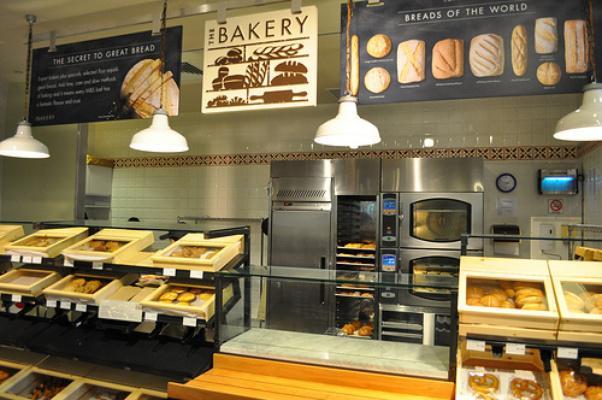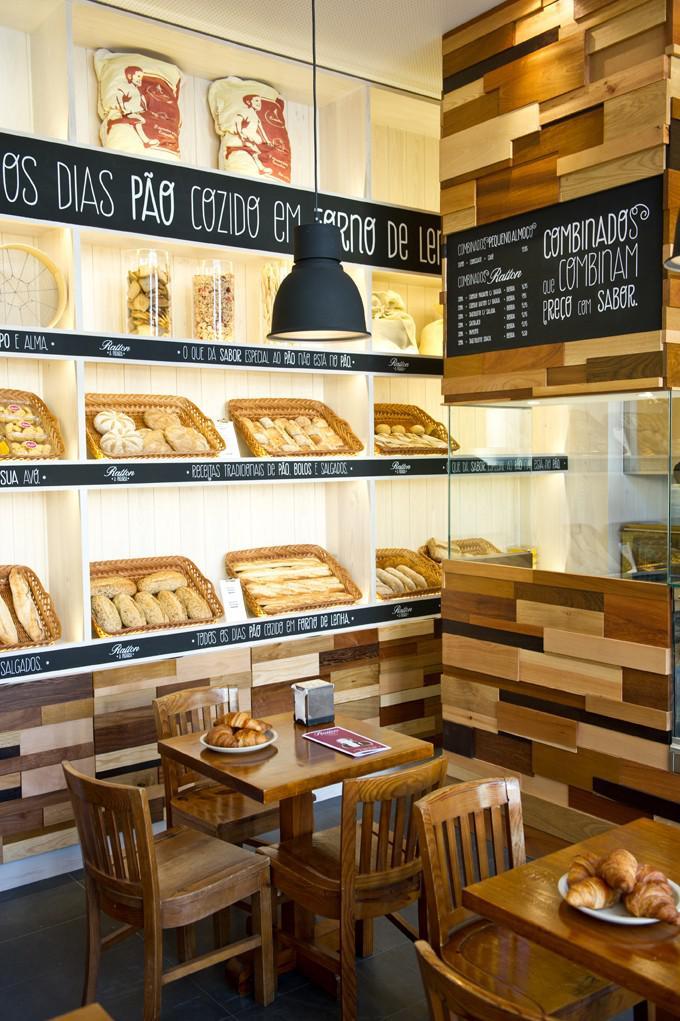The first image is the image on the left, the second image is the image on the right. Analyze the images presented: Is the assertion "Right image includes a row of at least 3 pendant lights." valid? Answer yes or no. No. 